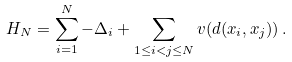<formula> <loc_0><loc_0><loc_500><loc_500>H _ { N } = \sum _ { i = 1 } ^ { N } - \Delta _ { i } + \sum _ { 1 \leq i < j \leq N } v ( d ( x _ { i } , x _ { j } ) ) \, .</formula> 